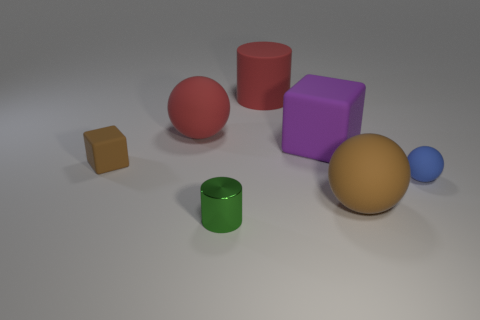What number of other things are the same size as the purple object? 3 